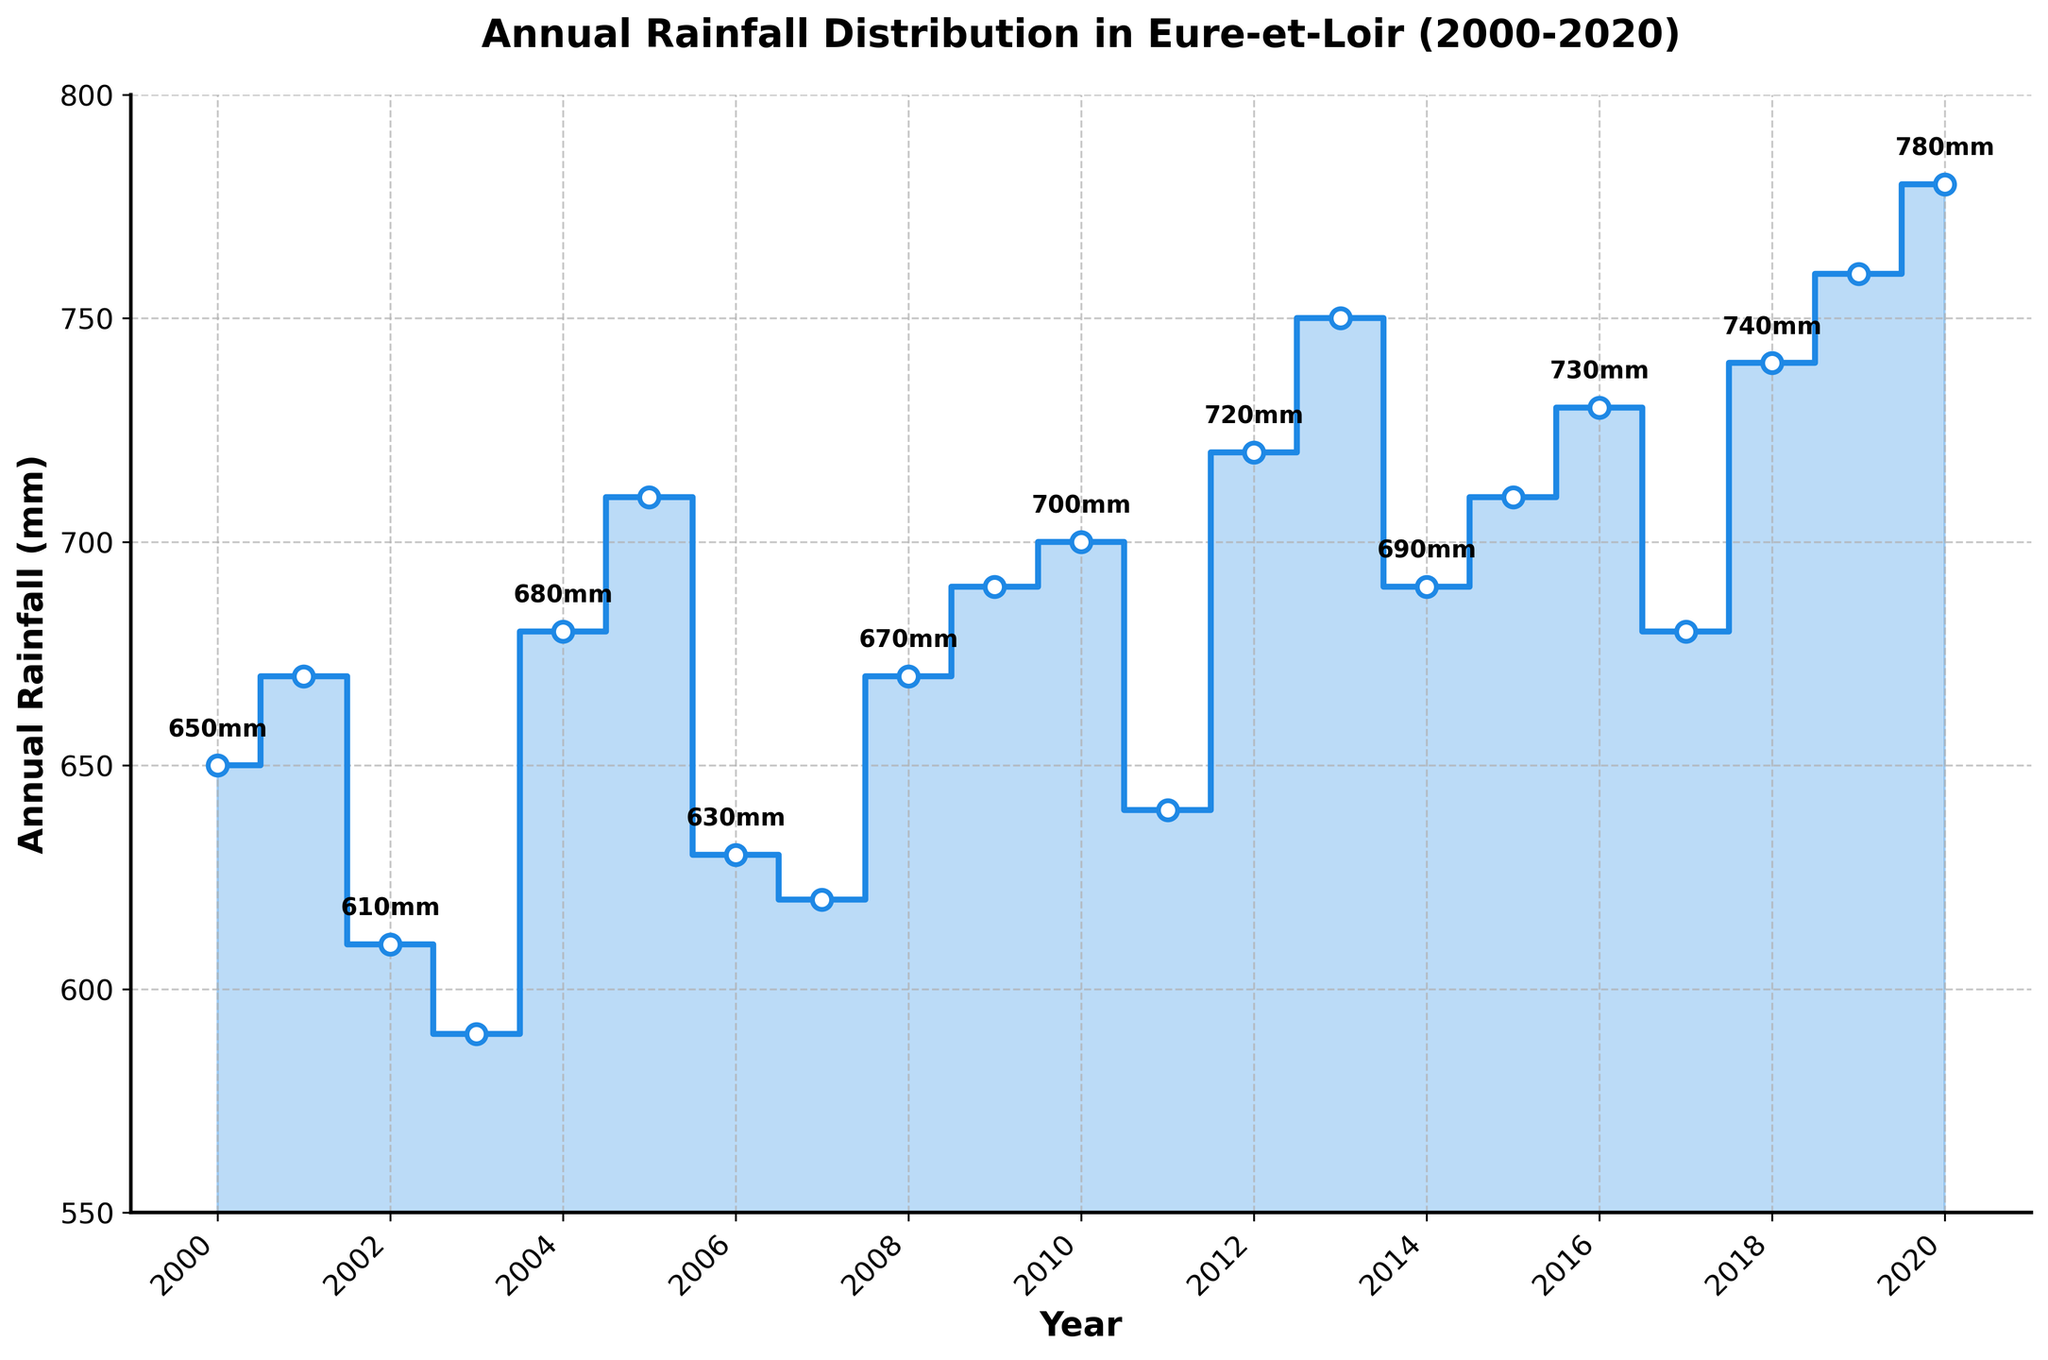What is the title of the plot? The title of the plot can be found at the top of the figure and it provides a summary of the data being displayed. Here, it states the subject and time range of the data.
Answer: Annual Rainfall Distribution in Eure-et-Loir (2000-2020) What is the highest annual rainfall recorded? To find the highest annual rainfall, look for the highest point on the stair plot. It's clearly marked with a value alongside the corresponding year.
Answer: 780 mm What is the lowest annual rainfall recorded? To find the lowest annual rainfall, look for the lowest point on the stair plot. It's clearly marked with a value alongside the corresponding year.
Answer: 590 mm What is the range of the annual rainfall values? The range is calculated by subtracting the minimum rainfall value from the maximum rainfall value. By locating the highest and lowest points on the plot, we can perform this calculation: 780 mm - 590 mm.
Answer: 190 mm What was the annual rainfall in 2010? To find the specific value for a given year, locate the year on the x-axis and follow it up to the corresponding point on the plot.
Answer: 700 mm How many years had annual rainfall greater than 700 mm? Compare the annual rainfall values against 700 mm and count the number of years where the value exceeded 700 mm. Those years are clearly marked on the plot.
Answer: 7 years What is the average annual rainfall from 2015 to 2020? To calculate the average, locate and sum the values from 2015 to 2020 on the plot: 710 + 730 + 680 + 740 + 760 + 780 = 4400 mm. Divide by the number of years (6).
Answer: 733.3 mm In which year did the rainfall see the most significant drop compared to the previous year? Identify the year-to-year differences in the plot. The largest drop can be found by visual inspection; look for the steepest downward step.
Answer: 2002 (from 670 mm in 2001 to 610 mm in 2002) Which year showed the most substantial increase in annual rainfall? Identify the year-to-year differences in the plot. The largest increase can be found by visual inspection; look for the steepest upward step.
Answer: 2018 (from 680 mm in 2017 to 740 mm in 2018) How did the annual rainfall trend over the 20-year period? Observe the general direction of the plot from 2000 to 2020. Summarize the overall trend considering the sequence of rises and falls over the period.
Answer: Increased 